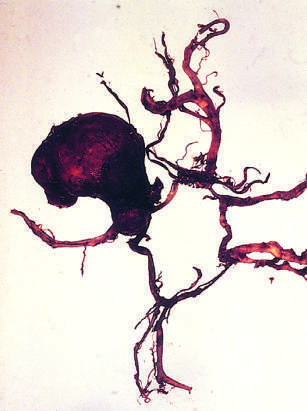s the circle of willis dissected to show a large aneurysm?
Answer the question using a single word or phrase. Yes 